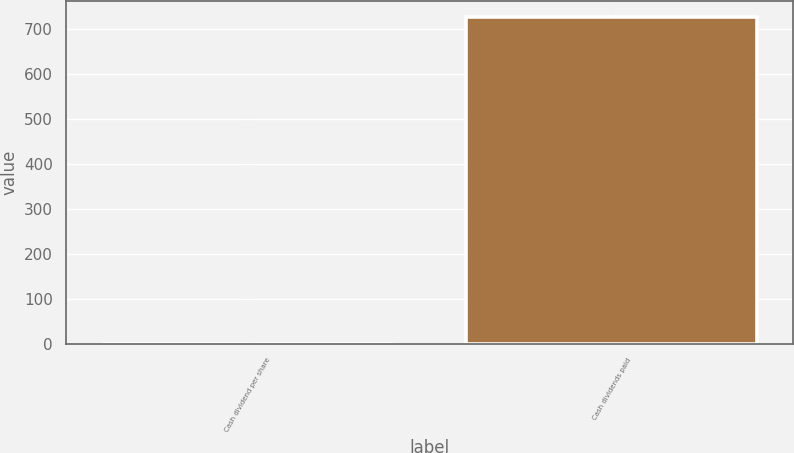<chart> <loc_0><loc_0><loc_500><loc_500><bar_chart><fcel>Cash dividend per share<fcel>Cash dividends paid<nl><fcel>0.64<fcel>727<nl></chart> 